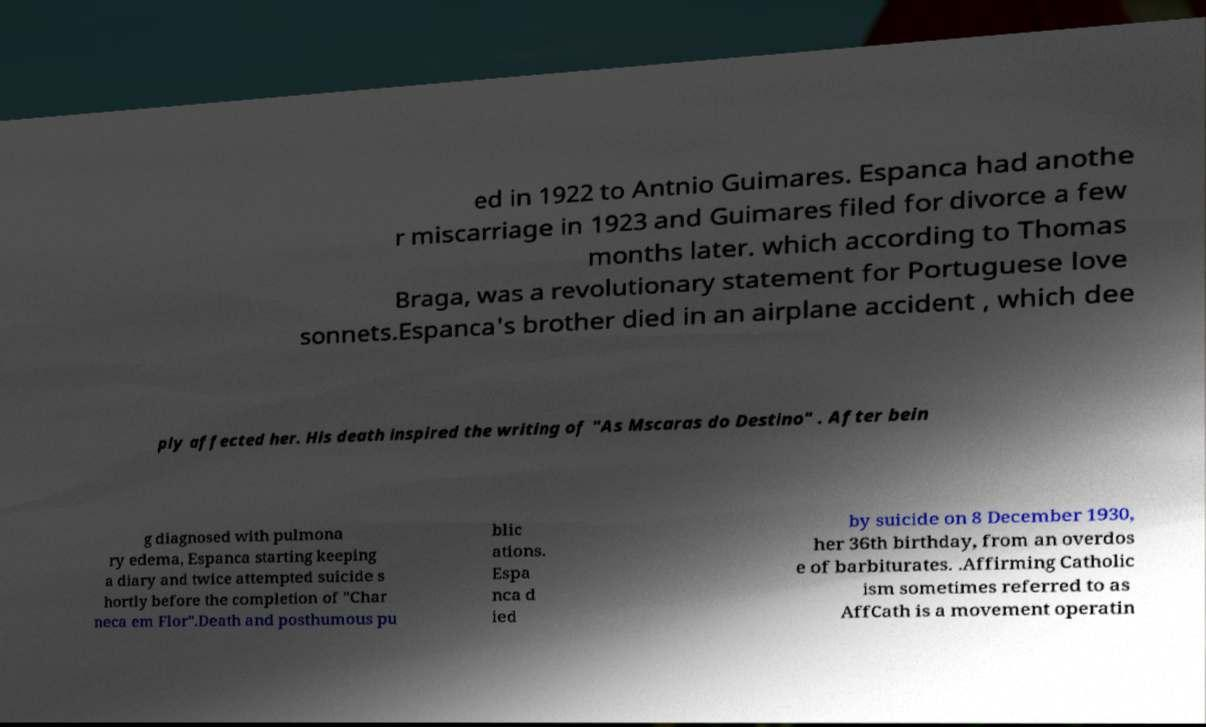There's text embedded in this image that I need extracted. Can you transcribe it verbatim? ed in 1922 to Antnio Guimares. Espanca had anothe r miscarriage in 1923 and Guimares filed for divorce a few months later. which according to Thomas Braga, was a revolutionary statement for Portuguese love sonnets.Espanca's brother died in an airplane accident , which dee ply affected her. His death inspired the writing of "As Mscaras do Destino" . After bein g diagnosed with pulmona ry edema, Espanca starting keeping a diary and twice attempted suicide s hortly before the completion of "Char neca em Flor".Death and posthumous pu blic ations. Espa nca d ied by suicide on 8 December 1930, her 36th birthday, from an overdos e of barbiturates. .Affirming Catholic ism sometimes referred to as AffCath is a movement operatin 